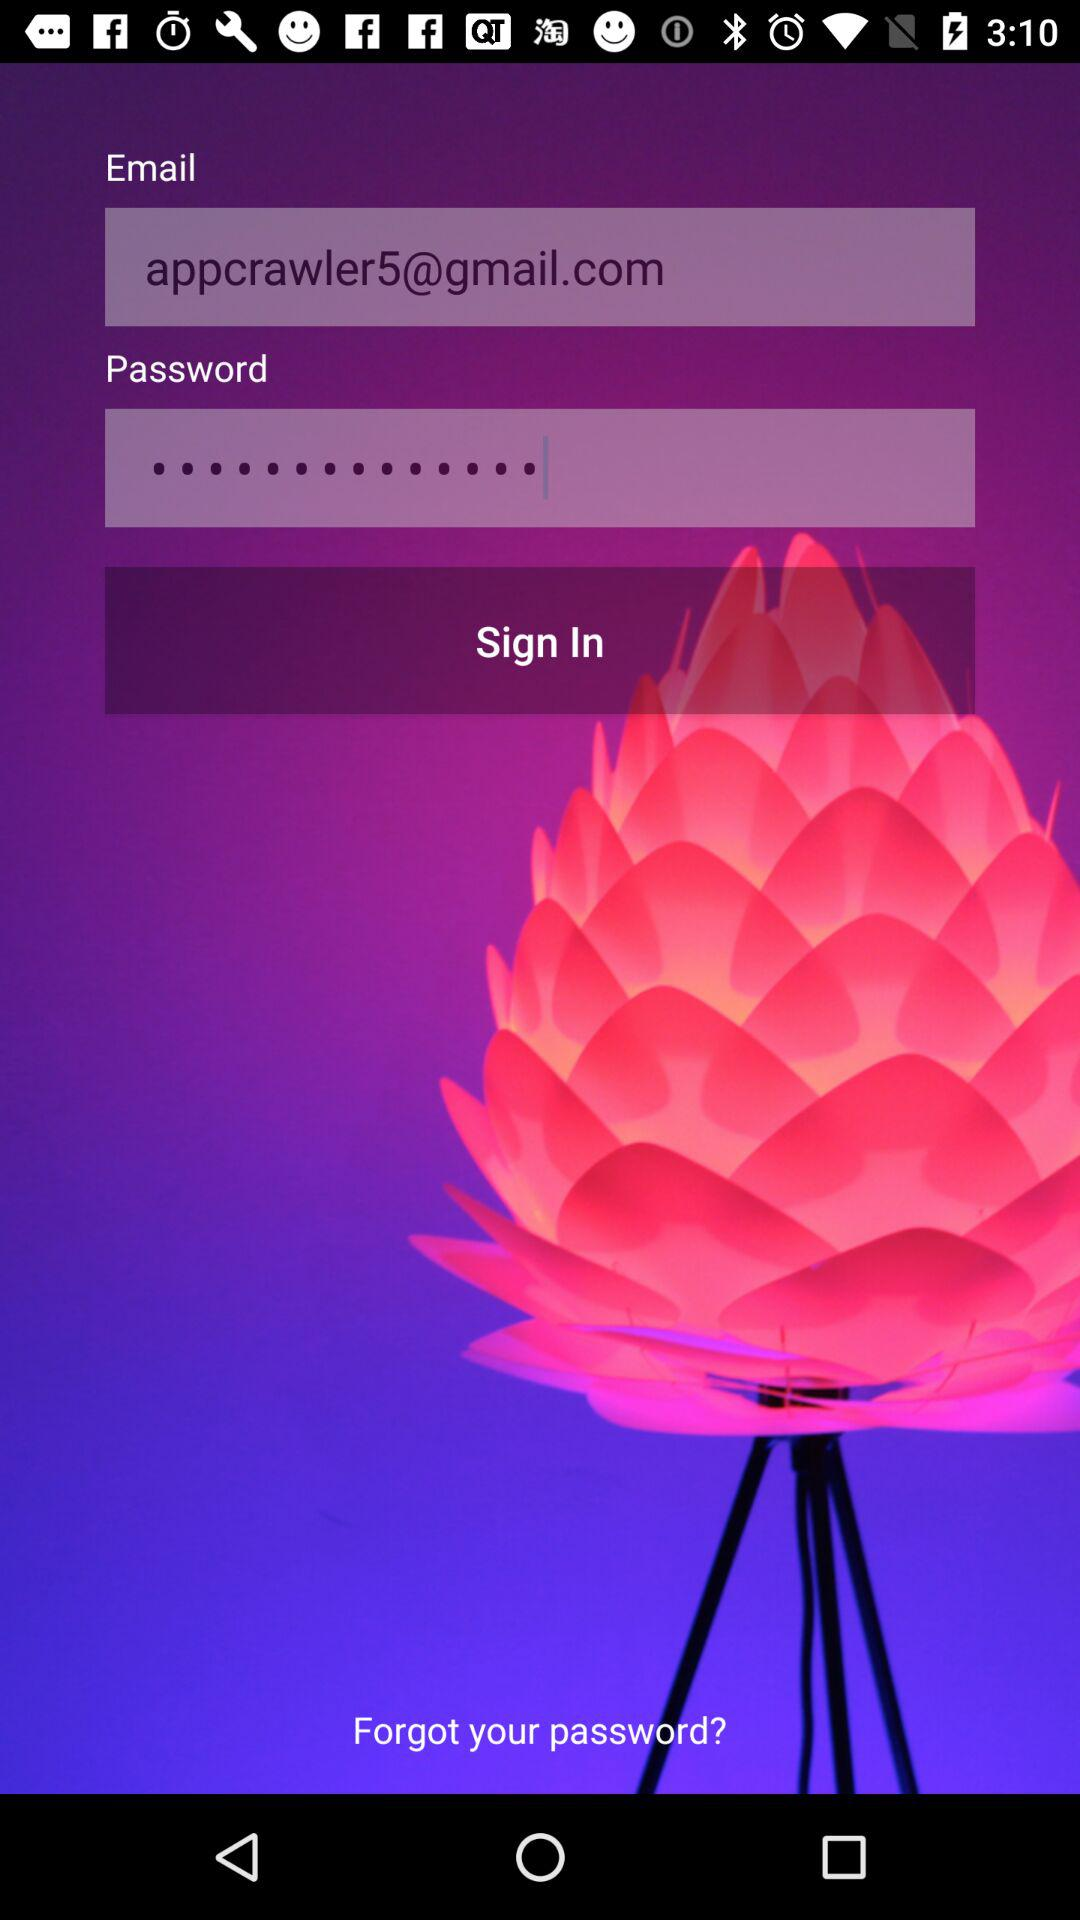What is the email address? The email address is appcrawler5@gmail.com. 